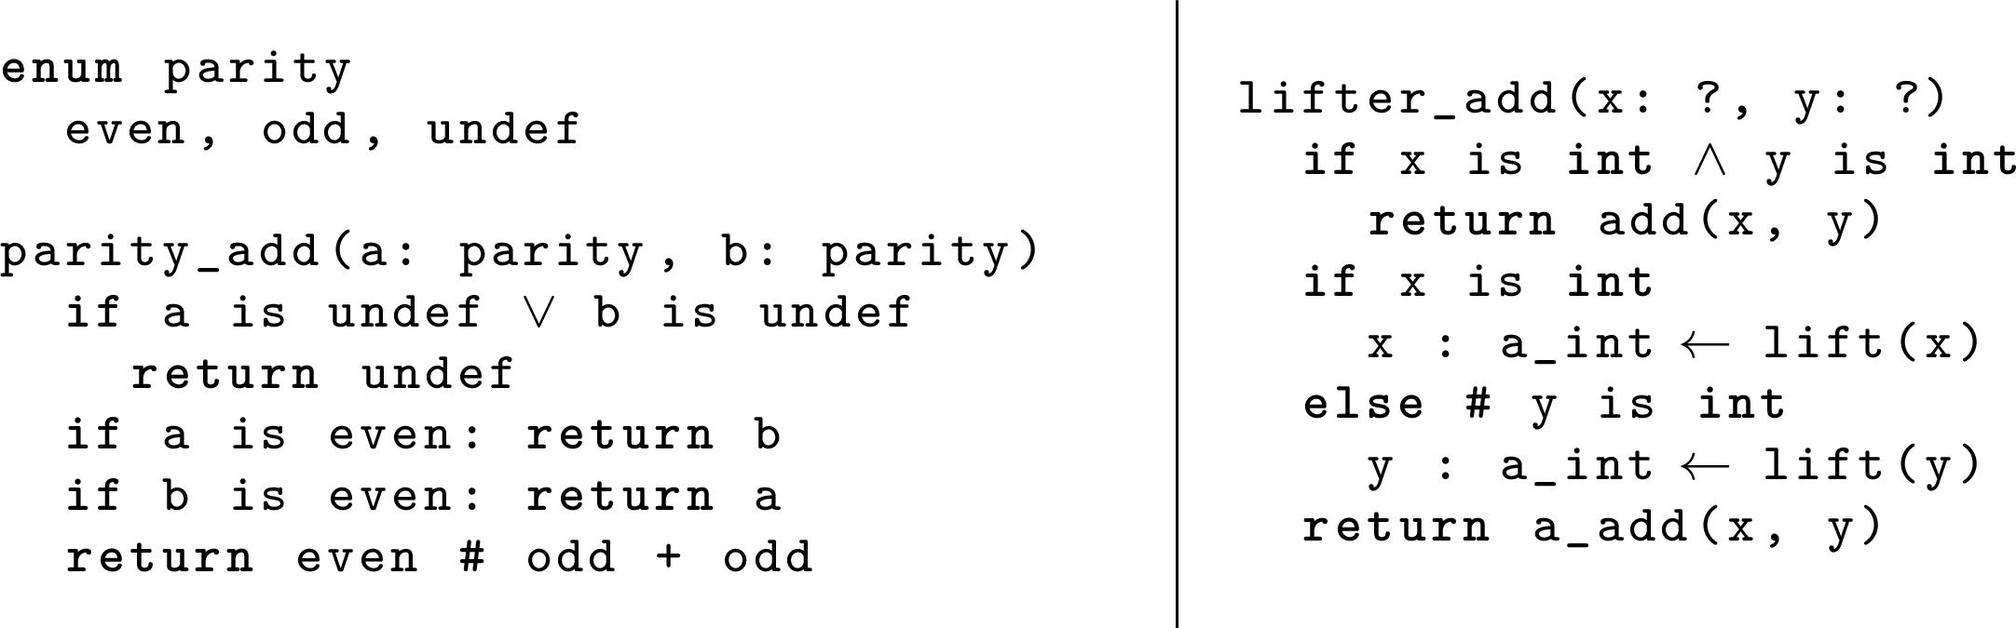Is there a scenario in the `parity_add` function where the result can be `odd`? Yes, based on the image’s depiction of the `parity_add` function, across the inputs provided, if one of them is `even` and the other is `odd`, the function would yield `odd`. Moreover, if both inputs are `odd`, the sum results in an `even` output. 